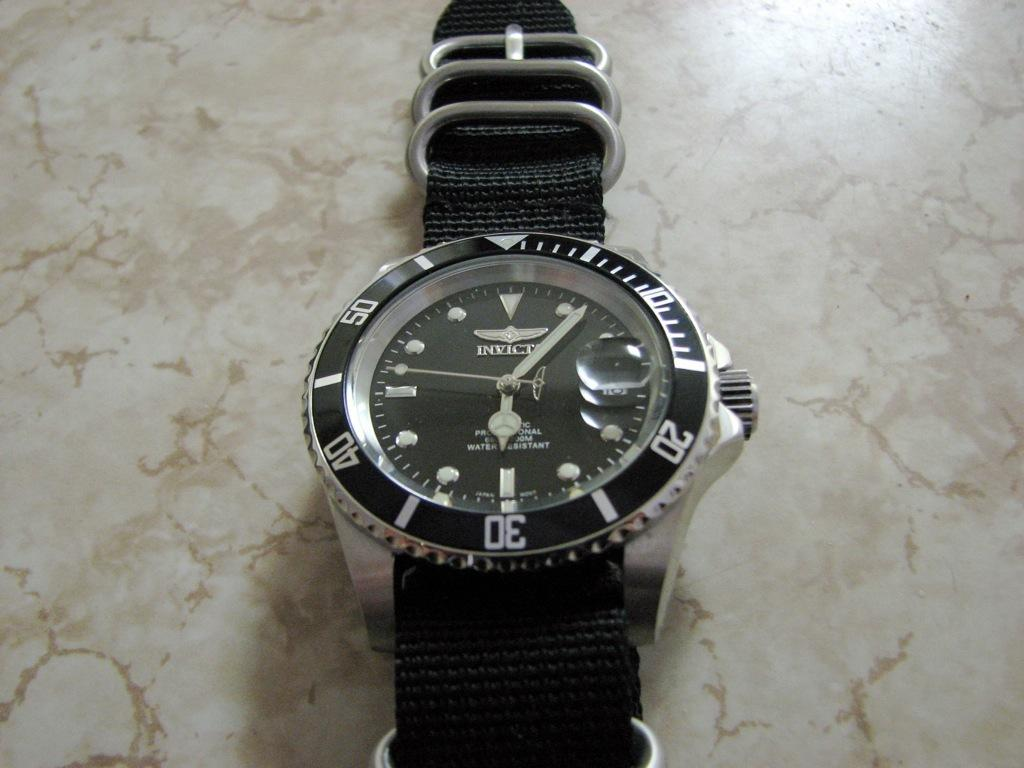What object is on the floor in the image? There is a watch on the floor in the image. What feature does the watch have? The watch has numbers on it. What type of destruction can be seen happening to the cows in the image? There are no cows or destruction present in the image; it features a watch on the floor. 